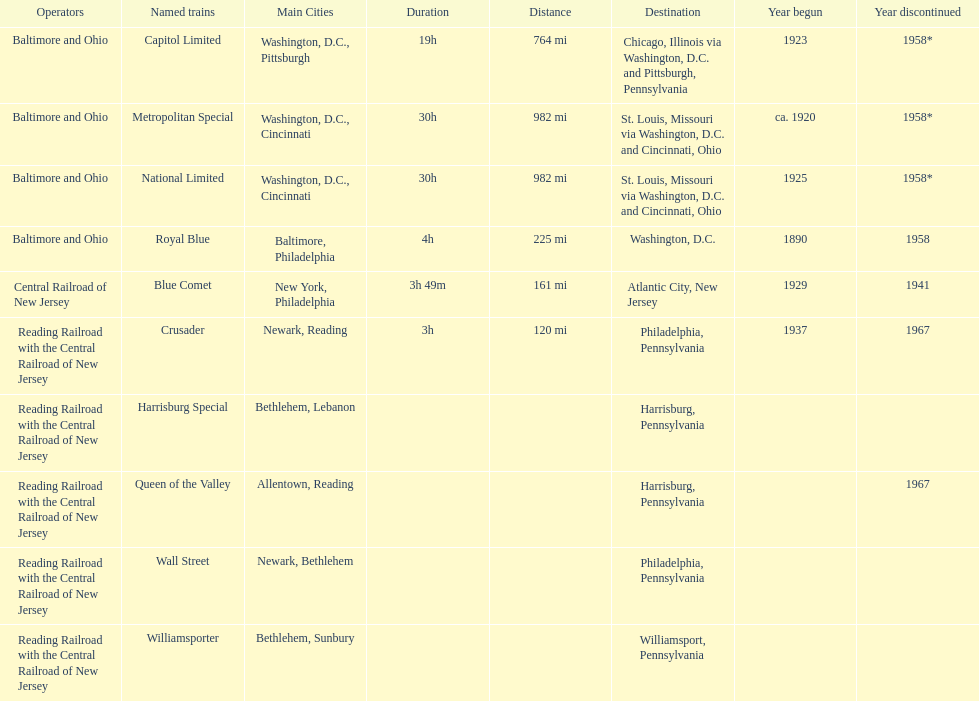Which train ran for the longest time? Royal Blue. 